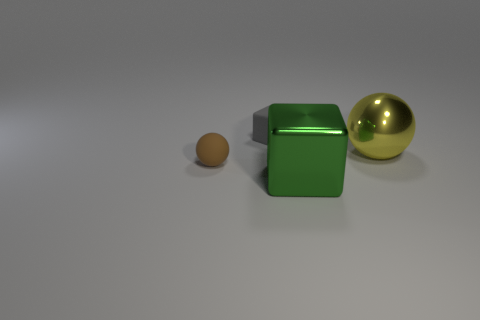Add 3 big yellow metal balls. How many objects exist? 7 Add 3 brown objects. How many brown objects exist? 4 Subtract 0 blue cubes. How many objects are left? 4 Subtract all rubber objects. Subtract all cyan matte cylinders. How many objects are left? 2 Add 3 gray objects. How many gray objects are left? 4 